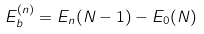<formula> <loc_0><loc_0><loc_500><loc_500>E _ { b } ^ { ( n ) } = E _ { n } ( N - 1 ) - E _ { 0 } ( N )</formula> 